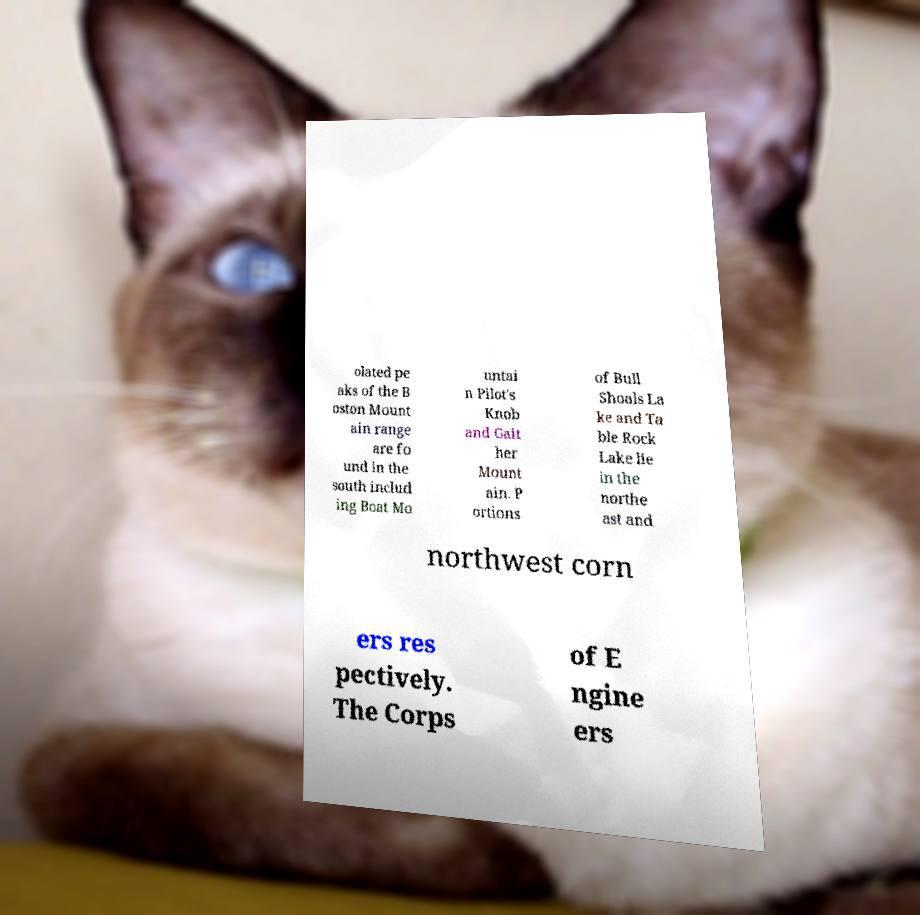Please read and relay the text visible in this image. What does it say? olated pe aks of the B oston Mount ain range are fo und in the south includ ing Boat Mo untai n Pilot's Knob and Gait her Mount ain. P ortions of Bull Shoals La ke and Ta ble Rock Lake lie in the northe ast and northwest corn ers res pectively. The Corps of E ngine ers 